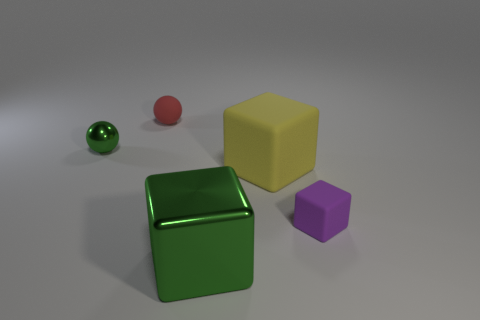Add 4 big brown matte blocks. How many objects exist? 9 Subtract all green cubes. How many cubes are left? 2 Subtract all purple cubes. How many cubes are left? 2 Subtract all spheres. How many objects are left? 3 Subtract all yellow blocks. Subtract all metal objects. How many objects are left? 2 Add 3 tiny purple rubber objects. How many tiny purple rubber objects are left? 4 Add 4 large green shiny blocks. How many large green shiny blocks exist? 5 Subtract 0 red blocks. How many objects are left? 5 Subtract 1 cubes. How many cubes are left? 2 Subtract all yellow spheres. Subtract all brown cylinders. How many spheres are left? 2 